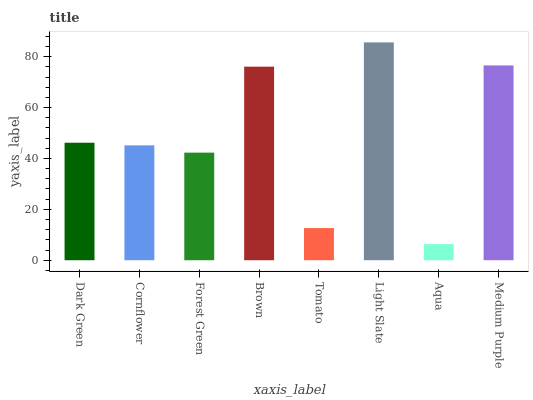Is Cornflower the minimum?
Answer yes or no. No. Is Cornflower the maximum?
Answer yes or no. No. Is Dark Green greater than Cornflower?
Answer yes or no. Yes. Is Cornflower less than Dark Green?
Answer yes or no. Yes. Is Cornflower greater than Dark Green?
Answer yes or no. No. Is Dark Green less than Cornflower?
Answer yes or no. No. Is Dark Green the high median?
Answer yes or no. Yes. Is Cornflower the low median?
Answer yes or no. Yes. Is Brown the high median?
Answer yes or no. No. Is Aqua the low median?
Answer yes or no. No. 